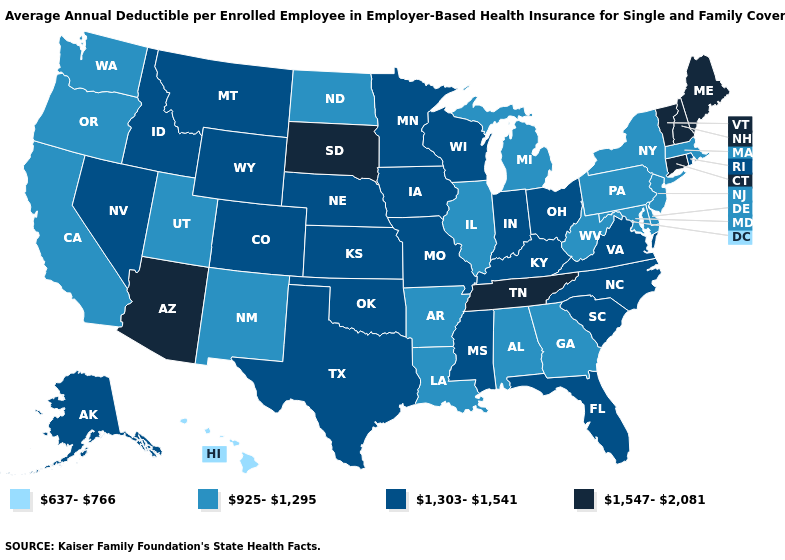Which states have the lowest value in the USA?
Quick response, please. Hawaii. Name the states that have a value in the range 925-1,295?
Answer briefly. Alabama, Arkansas, California, Delaware, Georgia, Illinois, Louisiana, Maryland, Massachusetts, Michigan, New Jersey, New Mexico, New York, North Dakota, Oregon, Pennsylvania, Utah, Washington, West Virginia. Name the states that have a value in the range 637-766?
Write a very short answer. Hawaii. Name the states that have a value in the range 1,303-1,541?
Concise answer only. Alaska, Colorado, Florida, Idaho, Indiana, Iowa, Kansas, Kentucky, Minnesota, Mississippi, Missouri, Montana, Nebraska, Nevada, North Carolina, Ohio, Oklahoma, Rhode Island, South Carolina, Texas, Virginia, Wisconsin, Wyoming. Which states have the highest value in the USA?
Give a very brief answer. Arizona, Connecticut, Maine, New Hampshire, South Dakota, Tennessee, Vermont. Which states have the lowest value in the MidWest?
Keep it brief. Illinois, Michigan, North Dakota. Name the states that have a value in the range 1,303-1,541?
Give a very brief answer. Alaska, Colorado, Florida, Idaho, Indiana, Iowa, Kansas, Kentucky, Minnesota, Mississippi, Missouri, Montana, Nebraska, Nevada, North Carolina, Ohio, Oklahoma, Rhode Island, South Carolina, Texas, Virginia, Wisconsin, Wyoming. Does Missouri have the highest value in the USA?
Be succinct. No. Does Hawaii have the lowest value in the West?
Concise answer only. Yes. Name the states that have a value in the range 925-1,295?
Keep it brief. Alabama, Arkansas, California, Delaware, Georgia, Illinois, Louisiana, Maryland, Massachusetts, Michigan, New Jersey, New Mexico, New York, North Dakota, Oregon, Pennsylvania, Utah, Washington, West Virginia. Does the map have missing data?
Concise answer only. No. What is the value of Wyoming?
Concise answer only. 1,303-1,541. What is the value of Massachusetts?
Give a very brief answer. 925-1,295. Name the states that have a value in the range 925-1,295?
Keep it brief. Alabama, Arkansas, California, Delaware, Georgia, Illinois, Louisiana, Maryland, Massachusetts, Michigan, New Jersey, New Mexico, New York, North Dakota, Oregon, Pennsylvania, Utah, Washington, West Virginia. Name the states that have a value in the range 925-1,295?
Answer briefly. Alabama, Arkansas, California, Delaware, Georgia, Illinois, Louisiana, Maryland, Massachusetts, Michigan, New Jersey, New Mexico, New York, North Dakota, Oregon, Pennsylvania, Utah, Washington, West Virginia. 